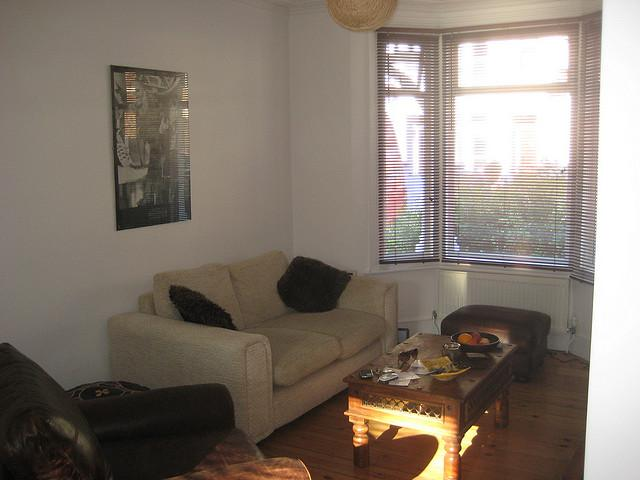What is on the wall? poster 